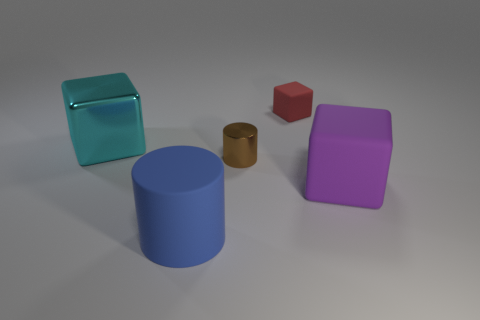Subtract all matte blocks. How many blocks are left? 1 Subtract all cylinders. How many objects are left? 3 Add 1 red metallic spheres. How many red metallic spheres exist? 1 Add 2 small brown objects. How many objects exist? 7 Subtract all blue cylinders. How many cylinders are left? 1 Subtract 0 yellow blocks. How many objects are left? 5 Subtract all cyan cylinders. Subtract all cyan balls. How many cylinders are left? 2 Subtract all blue cylinders. How many cyan cubes are left? 1 Subtract all big purple objects. Subtract all small red things. How many objects are left? 3 Add 3 big rubber blocks. How many big rubber blocks are left? 4 